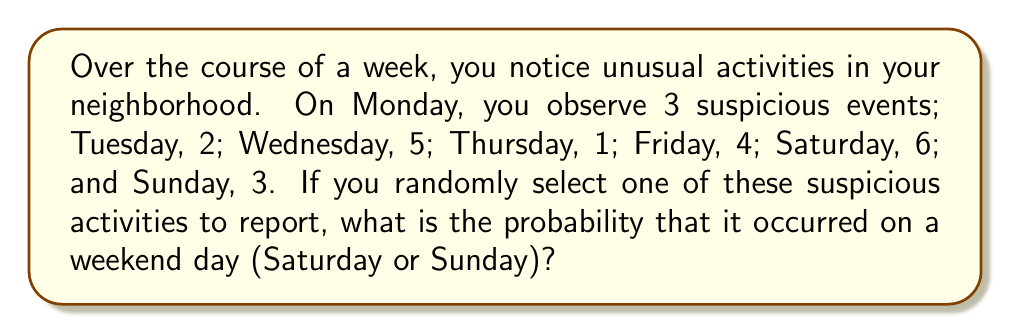What is the answer to this math problem? Let's approach this step-by-step:

1. First, we need to calculate the total number of suspicious activities observed throughout the week:
   $$3 + 2 + 5 + 1 + 4 + 6 + 3 = 24$$

2. Now, we identify the number of suspicious activities that occurred on weekend days:
   Saturday: 6
   Sunday: 3
   Total weekend activities: $$6 + 3 = 9$$

3. To calculate the probability, we use the formula:
   $$P(\text{weekend activity}) = \frac{\text{number of favorable outcomes}}{\text{total number of possible outcomes}}$$

4. Substituting our values:
   $$P(\text{weekend activity}) = \frac{9}{24}$$

5. This fraction can be reduced:
   $$\frac{9}{24} = \frac{3}{8}$$

Therefore, the probability of randomly selecting a suspicious activity that occurred on a weekend day is $\frac{3}{8}$.
Answer: $\frac{3}{8}$ 